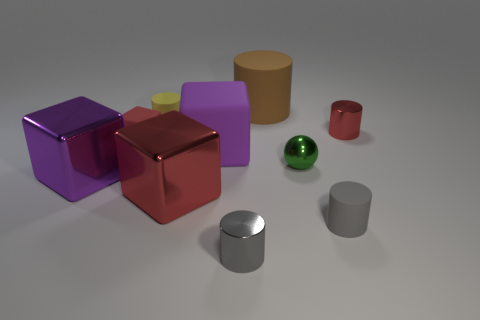What number of large things are purple matte objects or cyan rubber spheres?
Keep it short and to the point. 1. What is the size of the other metal block that is the same color as the small cube?
Your answer should be compact. Large. Are there any yellow objects that have the same material as the big brown cylinder?
Make the answer very short. Yes. There is a gray cylinder on the right side of the green metal object; what is it made of?
Your response must be concise. Rubber. There is a rubber cylinder that is on the left side of the large red object; is it the same color as the small cube on the left side of the gray matte cylinder?
Ensure brevity in your answer.  No. What color is the cube that is the same size as the metallic ball?
Offer a very short reply. Red. What number of other things are the same shape as the gray rubber object?
Your answer should be very brief. 4. There is a red metal object on the right side of the gray metallic thing; what is its size?
Provide a short and direct response. Small. There is a big purple thing behind the purple metal thing; how many metal cylinders are behind it?
Provide a short and direct response. 1. How many other objects are the same size as the yellow cylinder?
Offer a terse response. 5. 